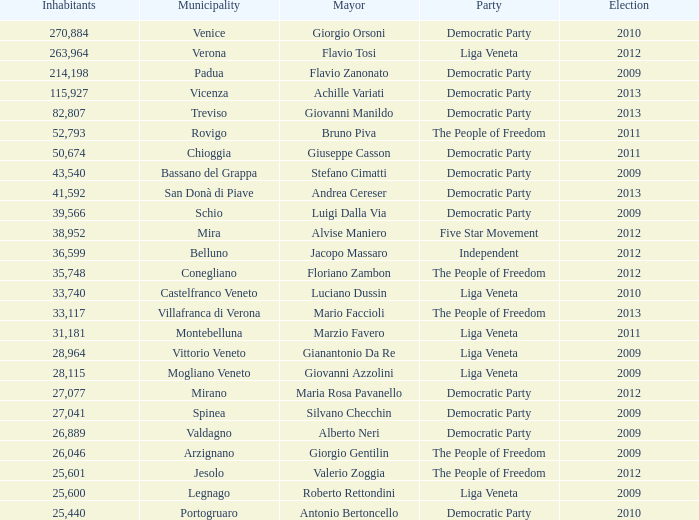What party was achille variati afilliated with? Democratic Party. 